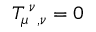<formula> <loc_0><loc_0><loc_500><loc_500>T _ { \mu ^ { \nu _ { , \nu } = 0</formula> 